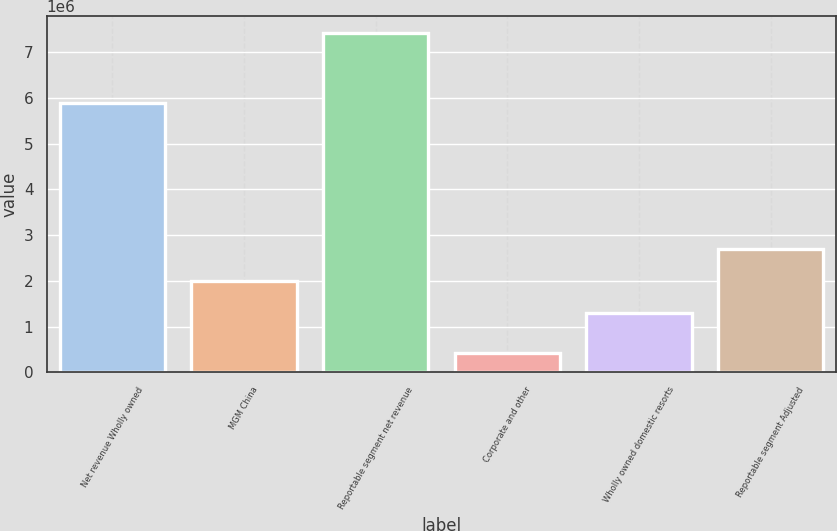Convert chart. <chart><loc_0><loc_0><loc_500><loc_500><bar_chart><fcel>Net revenue Wholly owned<fcel>MGM China<fcel>Reportable segment net revenue<fcel>Corporate and other<fcel>Wholly owned domestic resorts<fcel>Reportable segment Adjusted<nl><fcel>5.8929e+06<fcel>1.99876e+06<fcel>7.42786e+06<fcel>421447<fcel>1.29812e+06<fcel>2.6994e+06<nl></chart> 